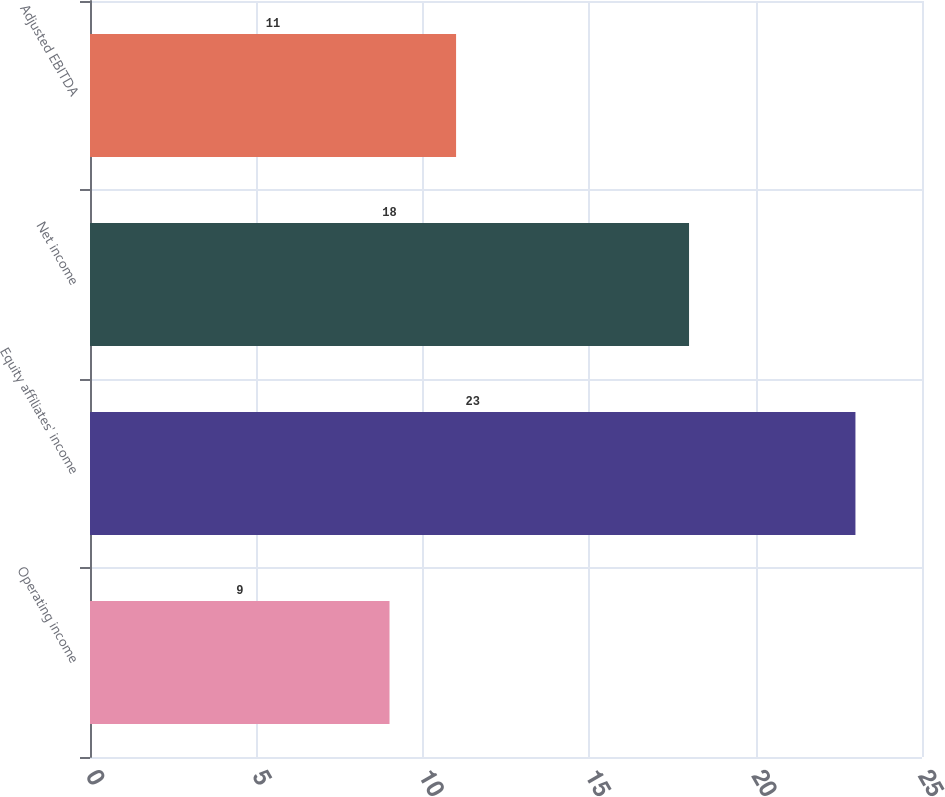Convert chart to OTSL. <chart><loc_0><loc_0><loc_500><loc_500><bar_chart><fcel>Operating income<fcel>Equity affiliates' income<fcel>Net income<fcel>Adjusted EBITDA<nl><fcel>9<fcel>23<fcel>18<fcel>11<nl></chart> 